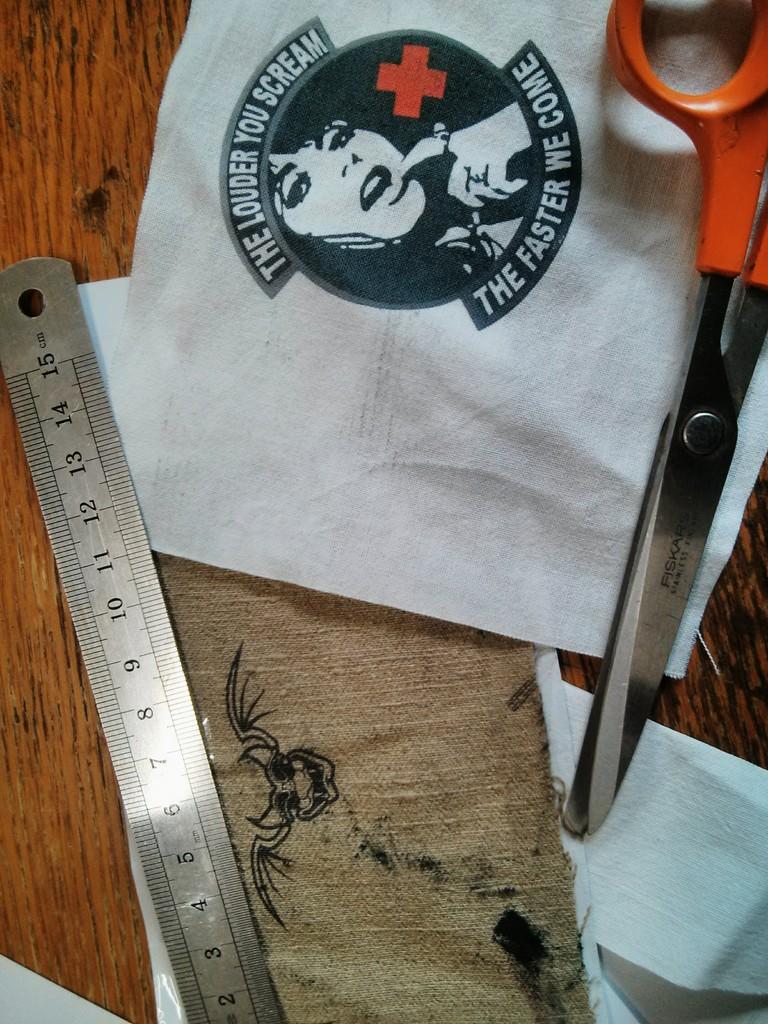What happens the louder you scream?
Provide a succinct answer. The faster we come. How many inches is that ruler?
Your response must be concise. 15. 